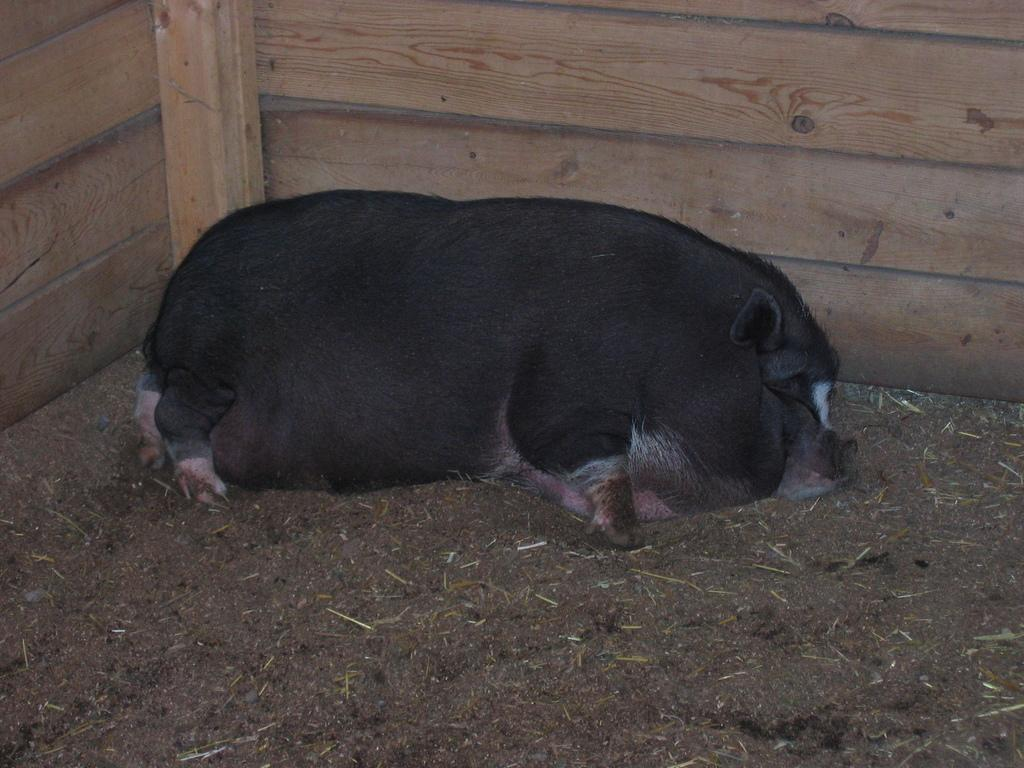What is the main subject of the image? There is an animal lying on the ground in the image. Can you describe the position of the animal? The animal is lying on the ground. What can be seen in the background of the image? There is a wooden object in the background of the image. What type of stone design is featured on the queen's dress in the image? There is no queen or stone design present in the image; it features an animal lying on the ground and a wooden object in the background. 